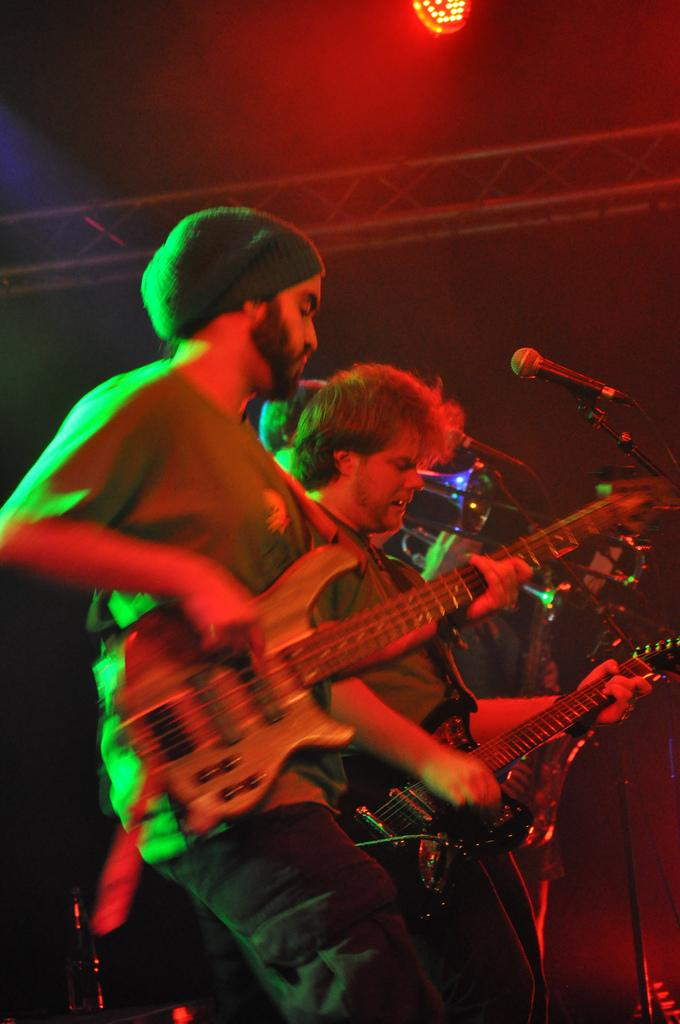How many people are in the image? There are two persons in the image. What are the persons doing in the image? The persons are playing guitar. What object is in front of the persons? There is a microphone in front of the persons. What type of light can be seen in the image? There is a focusing light in the image. What type of ship can be seen in the image? There is no ship, let alone a ship, present in the image. 